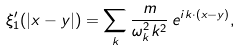Convert formula to latex. <formula><loc_0><loc_0><loc_500><loc_500>\xi _ { 1 } ^ { \prime } ( | { x - y } | ) = \sum _ { k } \frac { m } { \omega _ { k } ^ { 2 } k ^ { 2 } } \, e ^ { i { k \cdot ( x - y ) } } ,</formula> 